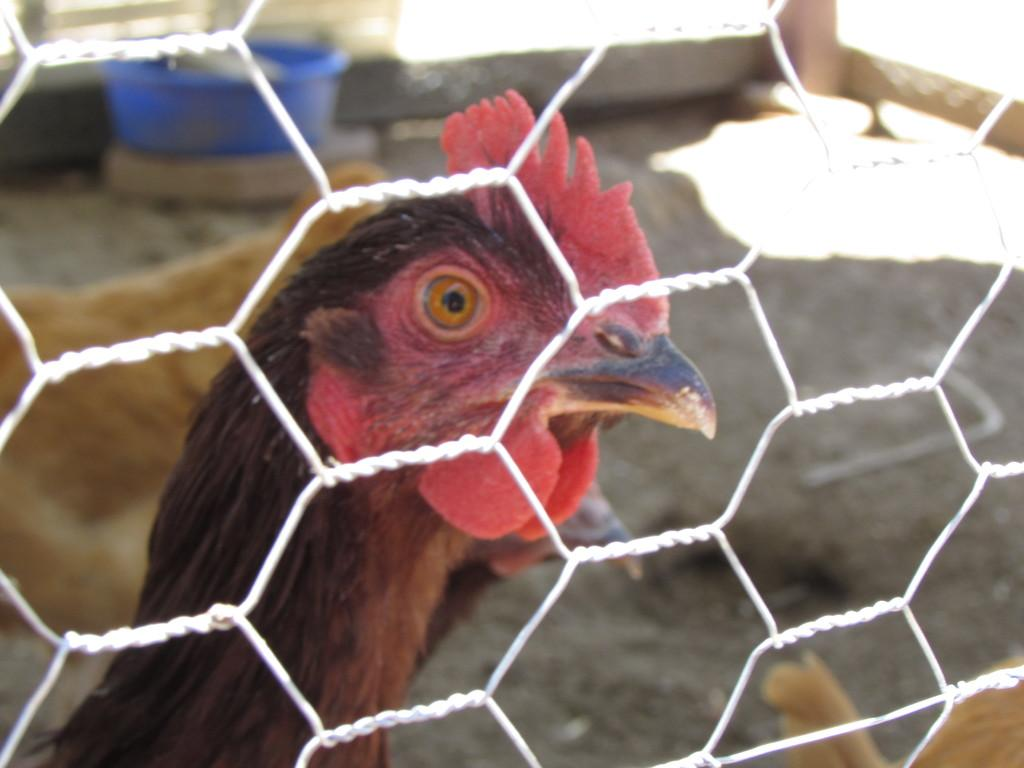What type of animal is present in the image? There is a hen in the image. Can you describe the hen's location in the image? The hen is behind a net. What type of map can be seen near the seashore in the image? There is no map or seashore present in the image; it features a hen behind a net. 